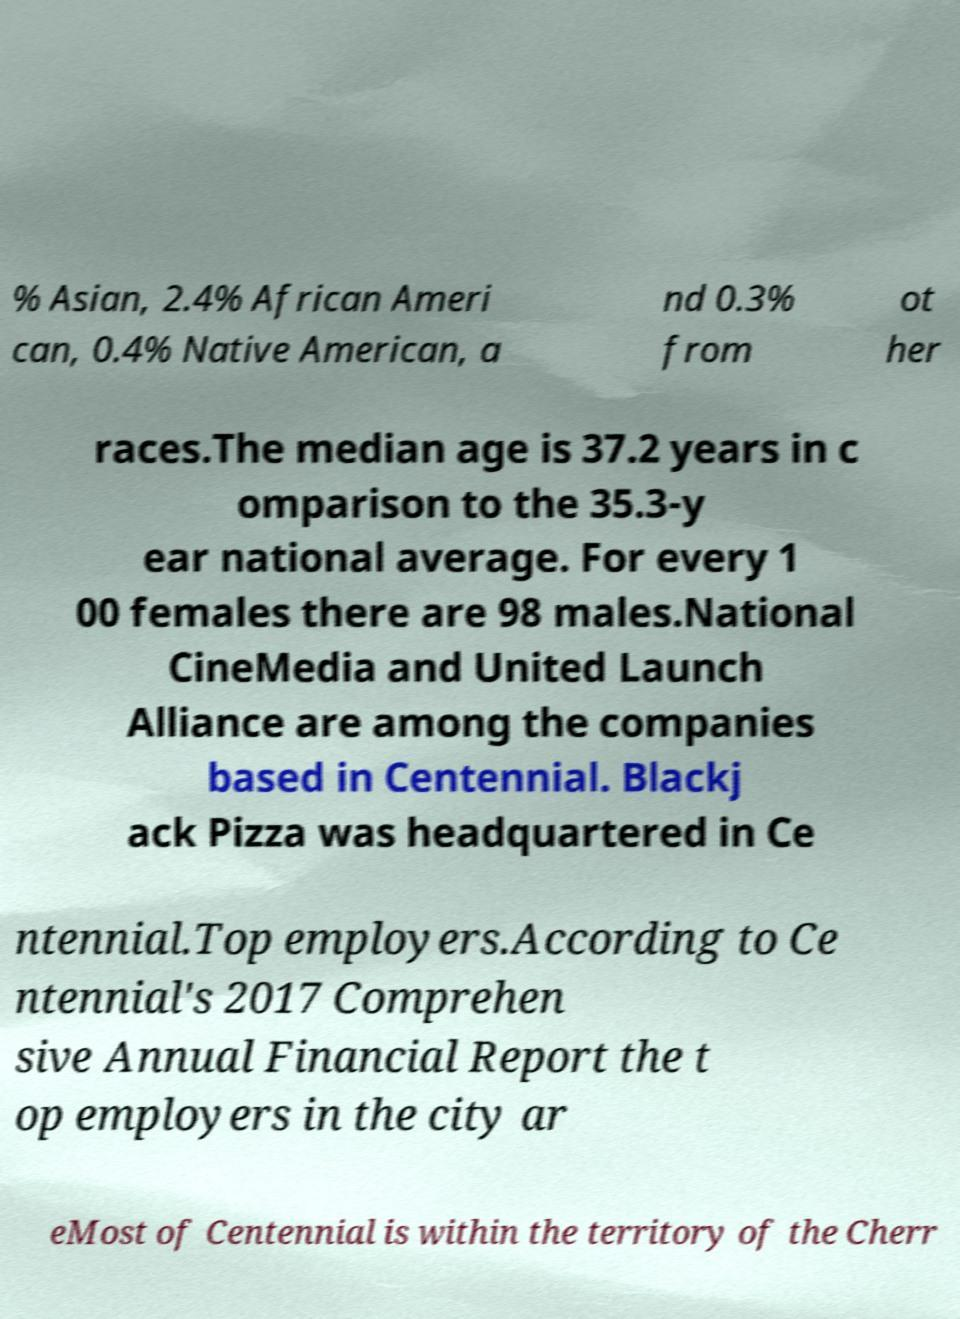For documentation purposes, I need the text within this image transcribed. Could you provide that? % Asian, 2.4% African Ameri can, 0.4% Native American, a nd 0.3% from ot her races.The median age is 37.2 years in c omparison to the 35.3-y ear national average. For every 1 00 females there are 98 males.National CineMedia and United Launch Alliance are among the companies based in Centennial. Blackj ack Pizza was headquartered in Ce ntennial.Top employers.According to Ce ntennial's 2017 Comprehen sive Annual Financial Report the t op employers in the city ar eMost of Centennial is within the territory of the Cherr 